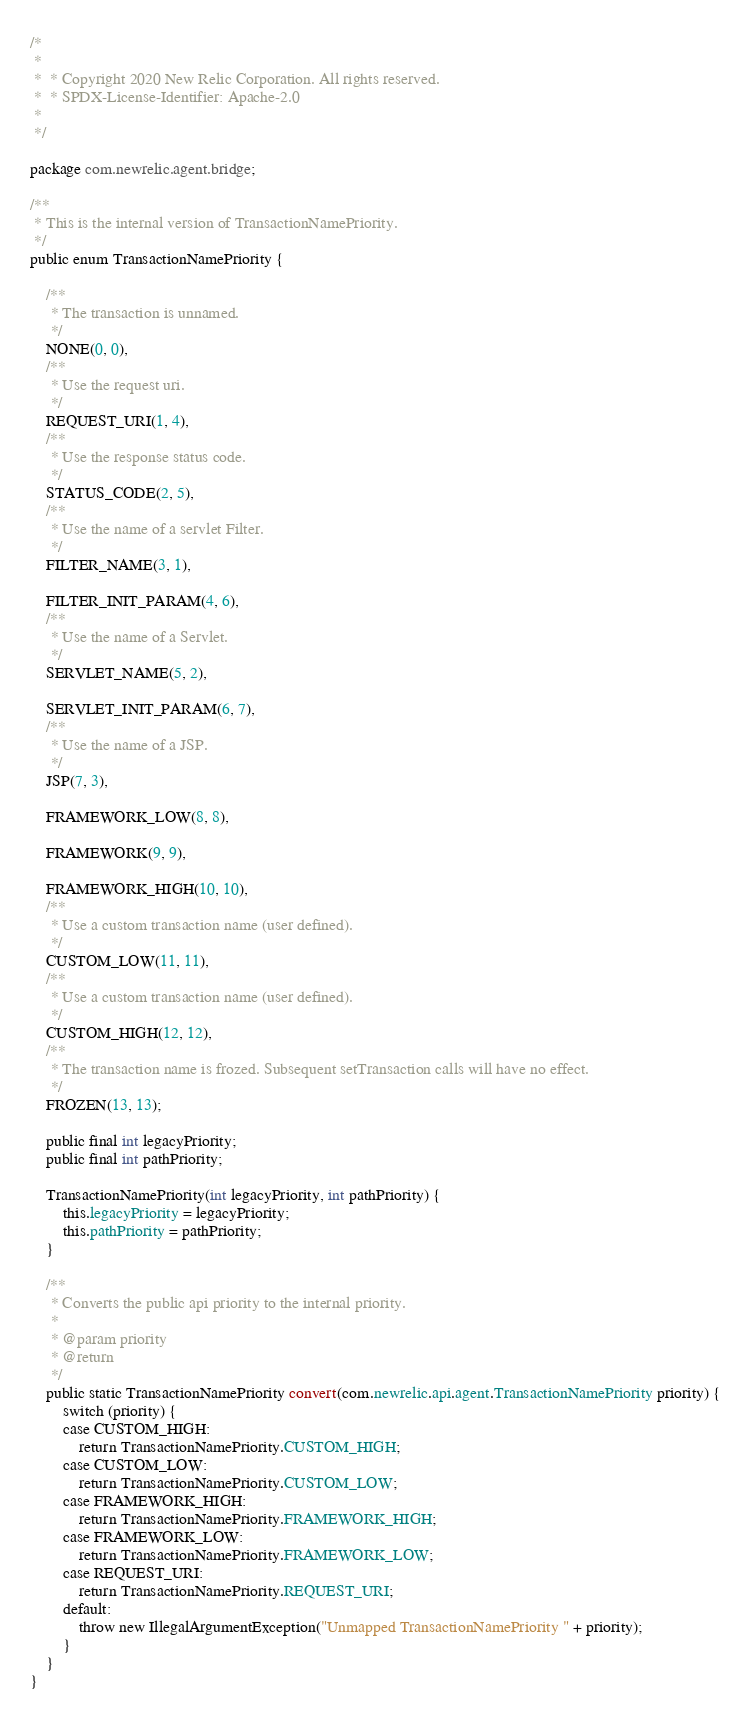Convert code to text. <code><loc_0><loc_0><loc_500><loc_500><_Java_>/*
 *
 *  * Copyright 2020 New Relic Corporation. All rights reserved.
 *  * SPDX-License-Identifier: Apache-2.0
 *
 */

package com.newrelic.agent.bridge;

/**
 * This is the internal version of TransactionNamePriority.
 */
public enum TransactionNamePriority {

    /**
     * The transaction is unnamed.
     */
    NONE(0, 0),
    /**
     * Use the request uri.
     */
    REQUEST_URI(1, 4),
    /**
     * Use the response status code.
     */
    STATUS_CODE(2, 5),
    /**
     * Use the name of a servlet Filter.
     */
    FILTER_NAME(3, 1),

    FILTER_INIT_PARAM(4, 6),
    /**
     * Use the name of a Servlet.
     */
    SERVLET_NAME(5, 2),

    SERVLET_INIT_PARAM(6, 7),
    /**
     * Use the name of a JSP.
     */
    JSP(7, 3),

    FRAMEWORK_LOW(8, 8),

    FRAMEWORK(9, 9),

    FRAMEWORK_HIGH(10, 10),
    /**
     * Use a custom transaction name (user defined).
     */
    CUSTOM_LOW(11, 11),
    /**
     * Use a custom transaction name (user defined).
     */
    CUSTOM_HIGH(12, 12),
    /**
     * The transaction name is frozed. Subsequent setTransaction calls will have no effect.
     */
    FROZEN(13, 13);

    public final int legacyPriority;
    public final int pathPriority;

    TransactionNamePriority(int legacyPriority, int pathPriority) {
        this.legacyPriority = legacyPriority;
        this.pathPriority = pathPriority;
    }

    /**
     * Converts the public api priority to the internal priority.
     * 
     * @param priority
     * @return
     */
    public static TransactionNamePriority convert(com.newrelic.api.agent.TransactionNamePriority priority) {
        switch (priority) {
        case CUSTOM_HIGH:
            return TransactionNamePriority.CUSTOM_HIGH;
        case CUSTOM_LOW:
            return TransactionNamePriority.CUSTOM_LOW;
        case FRAMEWORK_HIGH:
            return TransactionNamePriority.FRAMEWORK_HIGH;
        case FRAMEWORK_LOW:
            return TransactionNamePriority.FRAMEWORK_LOW;
        case REQUEST_URI:
            return TransactionNamePriority.REQUEST_URI;
        default:
            throw new IllegalArgumentException("Unmapped TransactionNamePriority " + priority);
        }
    }
}
</code> 